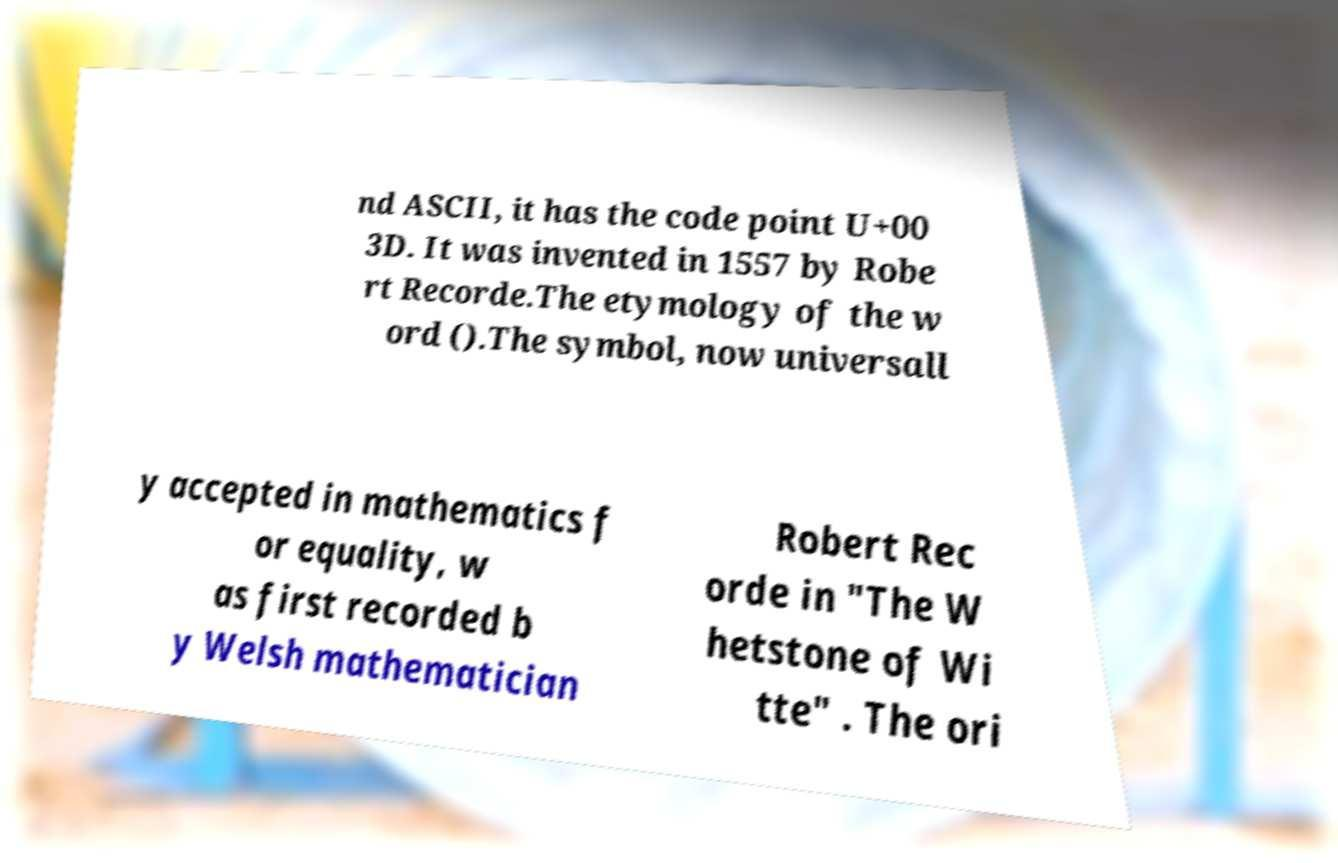For documentation purposes, I need the text within this image transcribed. Could you provide that? nd ASCII, it has the code point U+00 3D. It was invented in 1557 by Robe rt Recorde.The etymology of the w ord ().The symbol, now universall y accepted in mathematics f or equality, w as first recorded b y Welsh mathematician Robert Rec orde in "The W hetstone of Wi tte" . The ori 